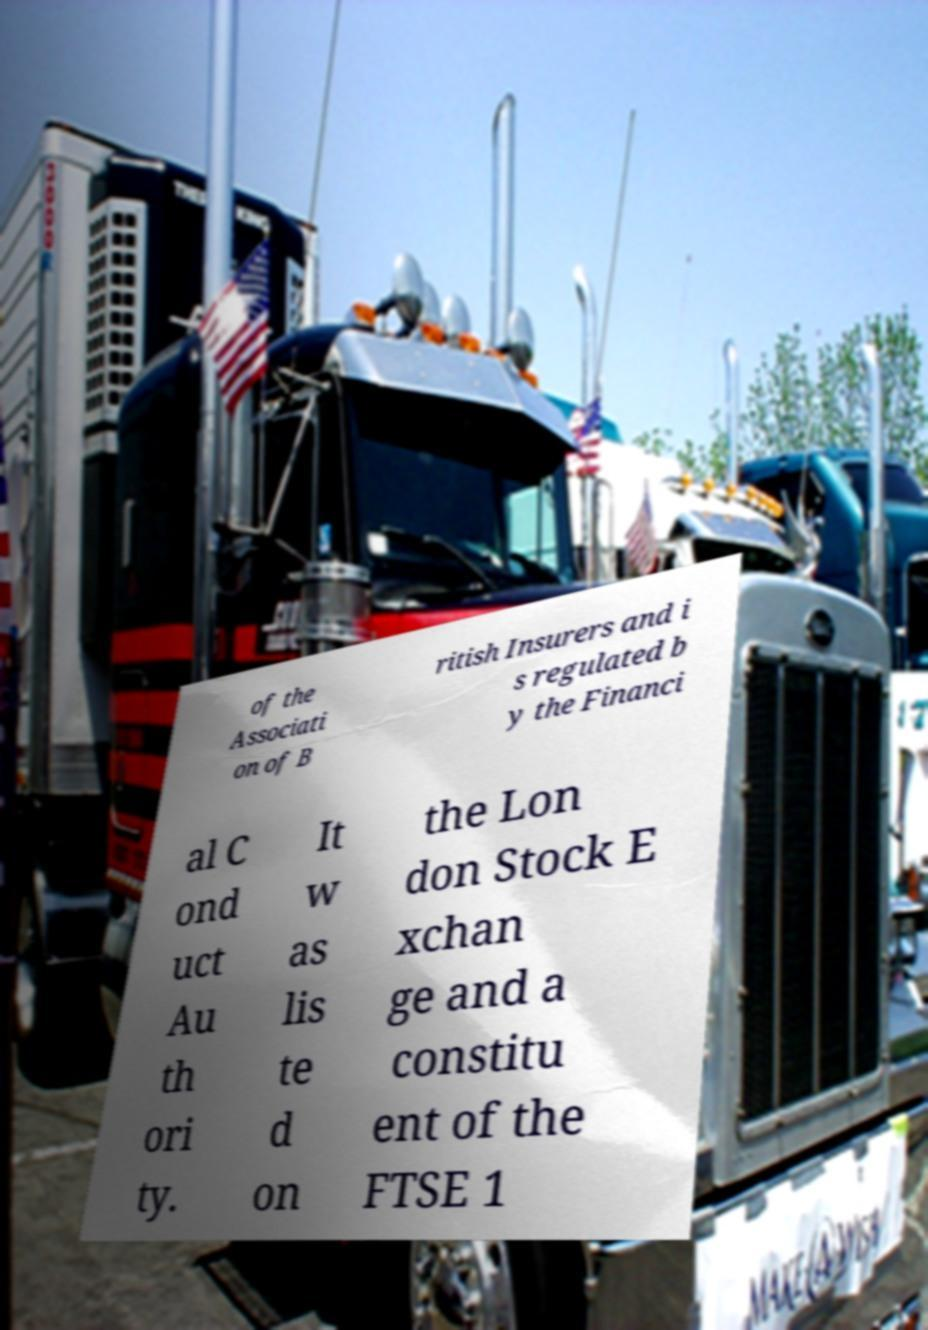There's text embedded in this image that I need extracted. Can you transcribe it verbatim? of the Associati on of B ritish Insurers and i s regulated b y the Financi al C ond uct Au th ori ty. It w as lis te d on the Lon don Stock E xchan ge and a constitu ent of the FTSE 1 